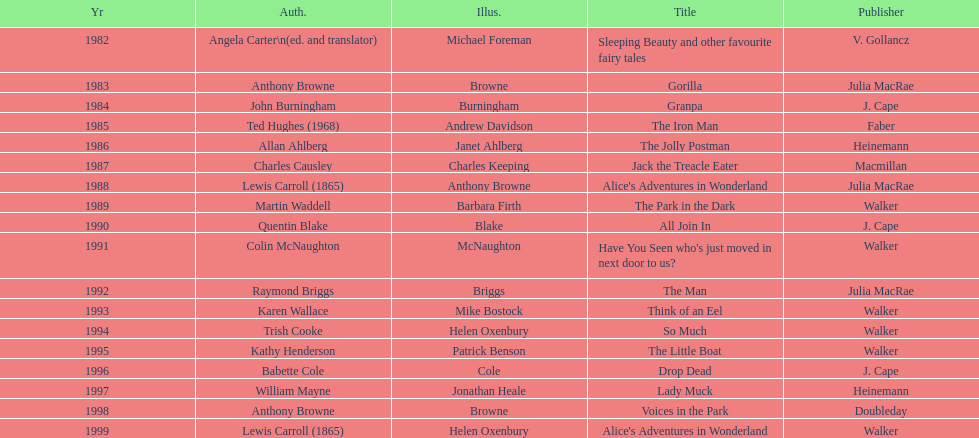Which book won the award a total of 2 times? Alice's Adventures in Wonderland. 